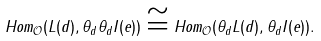Convert formula to latex. <formula><loc_0><loc_0><loc_500><loc_500>H o m _ { \mathcal { O } } ( L ( d ) , \theta _ { d } \theta _ { d } I ( e ) ) \cong H o m _ { \mathcal { O } } ( \theta _ { d } L ( d ) , \theta _ { d } I ( e ) ) .</formula> 